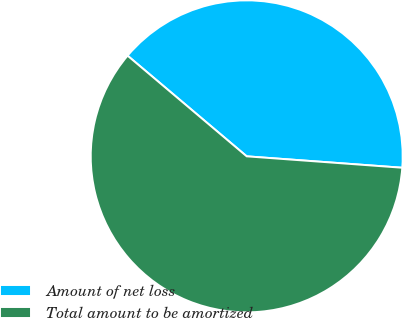Convert chart to OTSL. <chart><loc_0><loc_0><loc_500><loc_500><pie_chart><fcel>Amount of net loss<fcel>Total amount to be amortized<nl><fcel>40.0%<fcel>60.0%<nl></chart> 